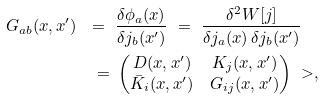<formula> <loc_0><loc_0><loc_500><loc_500>G _ { a b } ( x , x ^ { \prime } ) \ = \ & \frac { \delta \phi _ { a } ( x ) } { \delta j _ { b } ( x ^ { \prime } ) } \ = \ \frac { \delta ^ { 2 } W [ j ] } { \delta j _ { a } ( x ) \, \delta j _ { b } ( x ^ { \prime } ) } \\ \ = \ & \begin{pmatrix} D ( x , x ^ { \prime } ) & K _ { j } ( x , x ^ { \prime } ) \\ \bar { K } _ { i } ( x , x ^ { \prime } ) & G _ { i j } ( x , x ^ { \prime } ) \end{pmatrix} \ > ,</formula> 